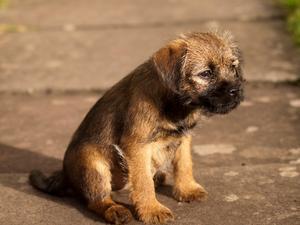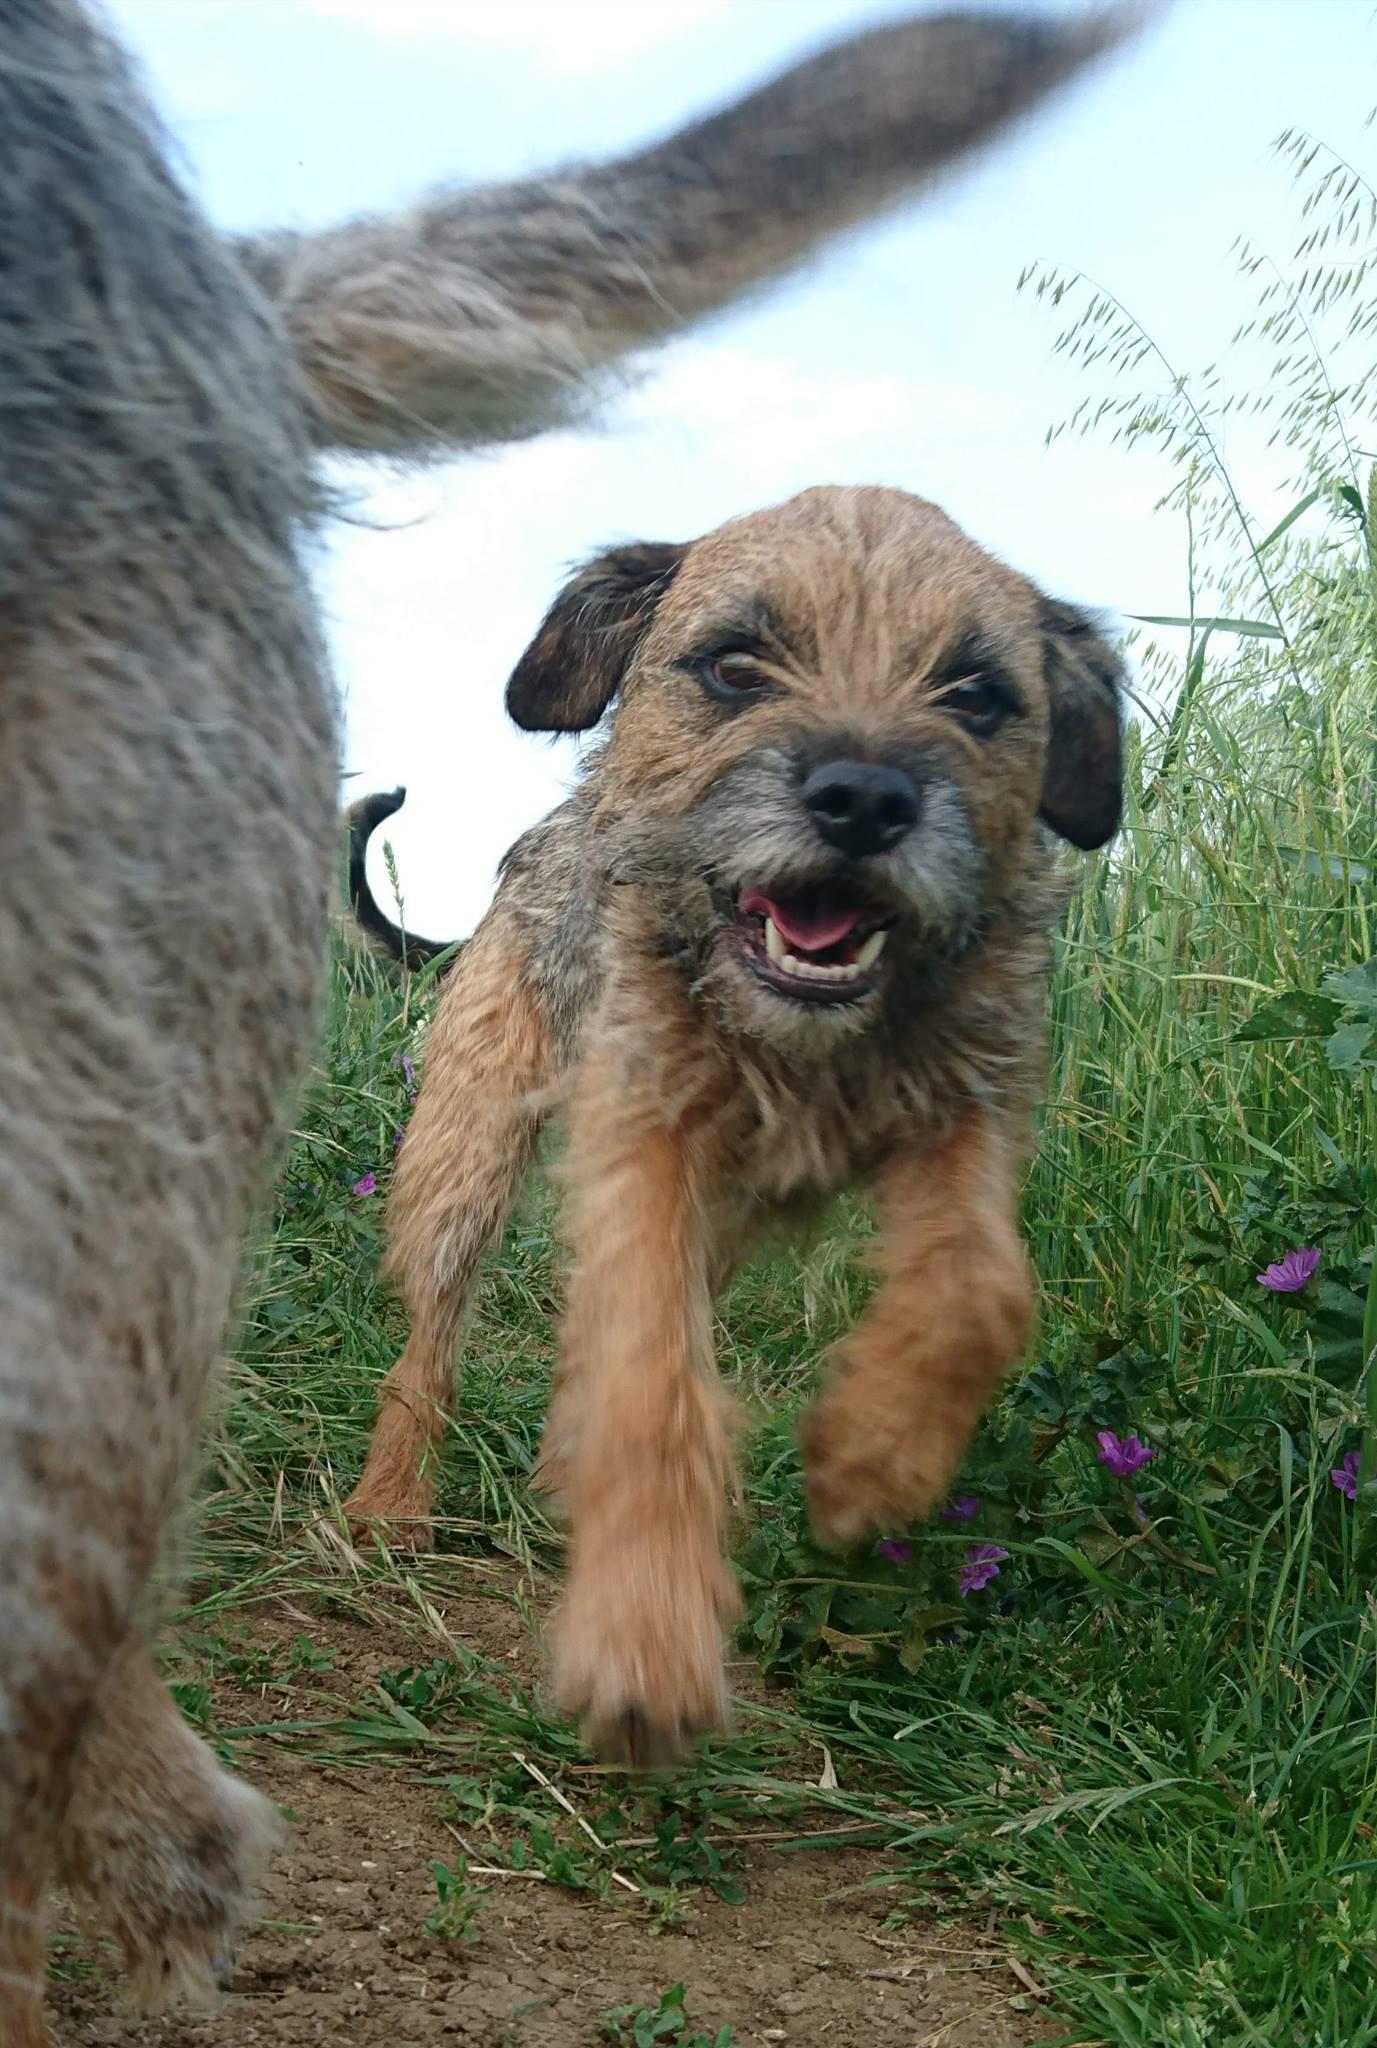The first image is the image on the left, the second image is the image on the right. Assess this claim about the two images: "The left and right image contains the same number of dogs facing the same directions.". Correct or not? Answer yes or no. No. The first image is the image on the left, the second image is the image on the right. Examine the images to the left and right. Is the description "In one image a dog is in the grass, moving forward with its left leg higher than the right and has its mouth open." accurate? Answer yes or no. Yes. 